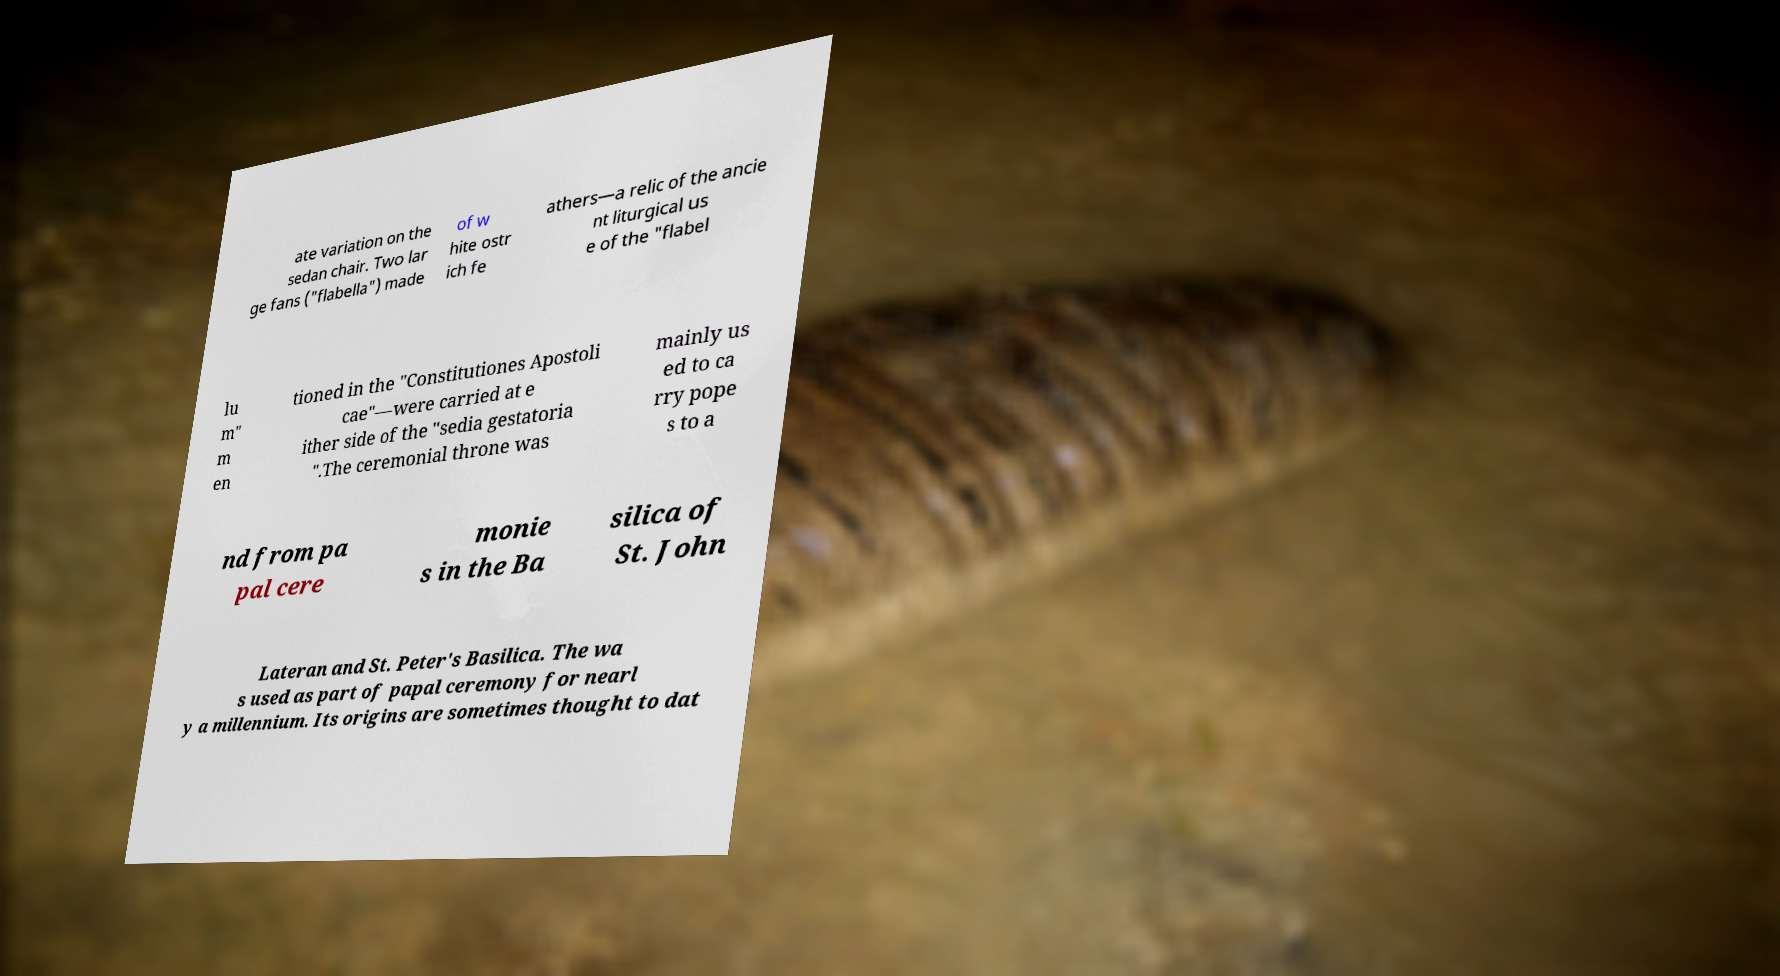Please read and relay the text visible in this image. What does it say? ate variation on the sedan chair. Two lar ge fans ("flabella") made of w hite ostr ich fe athers—a relic of the ancie nt liturgical us e of the "flabel lu m" m en tioned in the "Constitutiones Apostoli cae"—were carried at e ither side of the "sedia gestatoria ".The ceremonial throne was mainly us ed to ca rry pope s to a nd from pa pal cere monie s in the Ba silica of St. John Lateran and St. Peter's Basilica. The wa s used as part of papal ceremony for nearl y a millennium. Its origins are sometimes thought to dat 